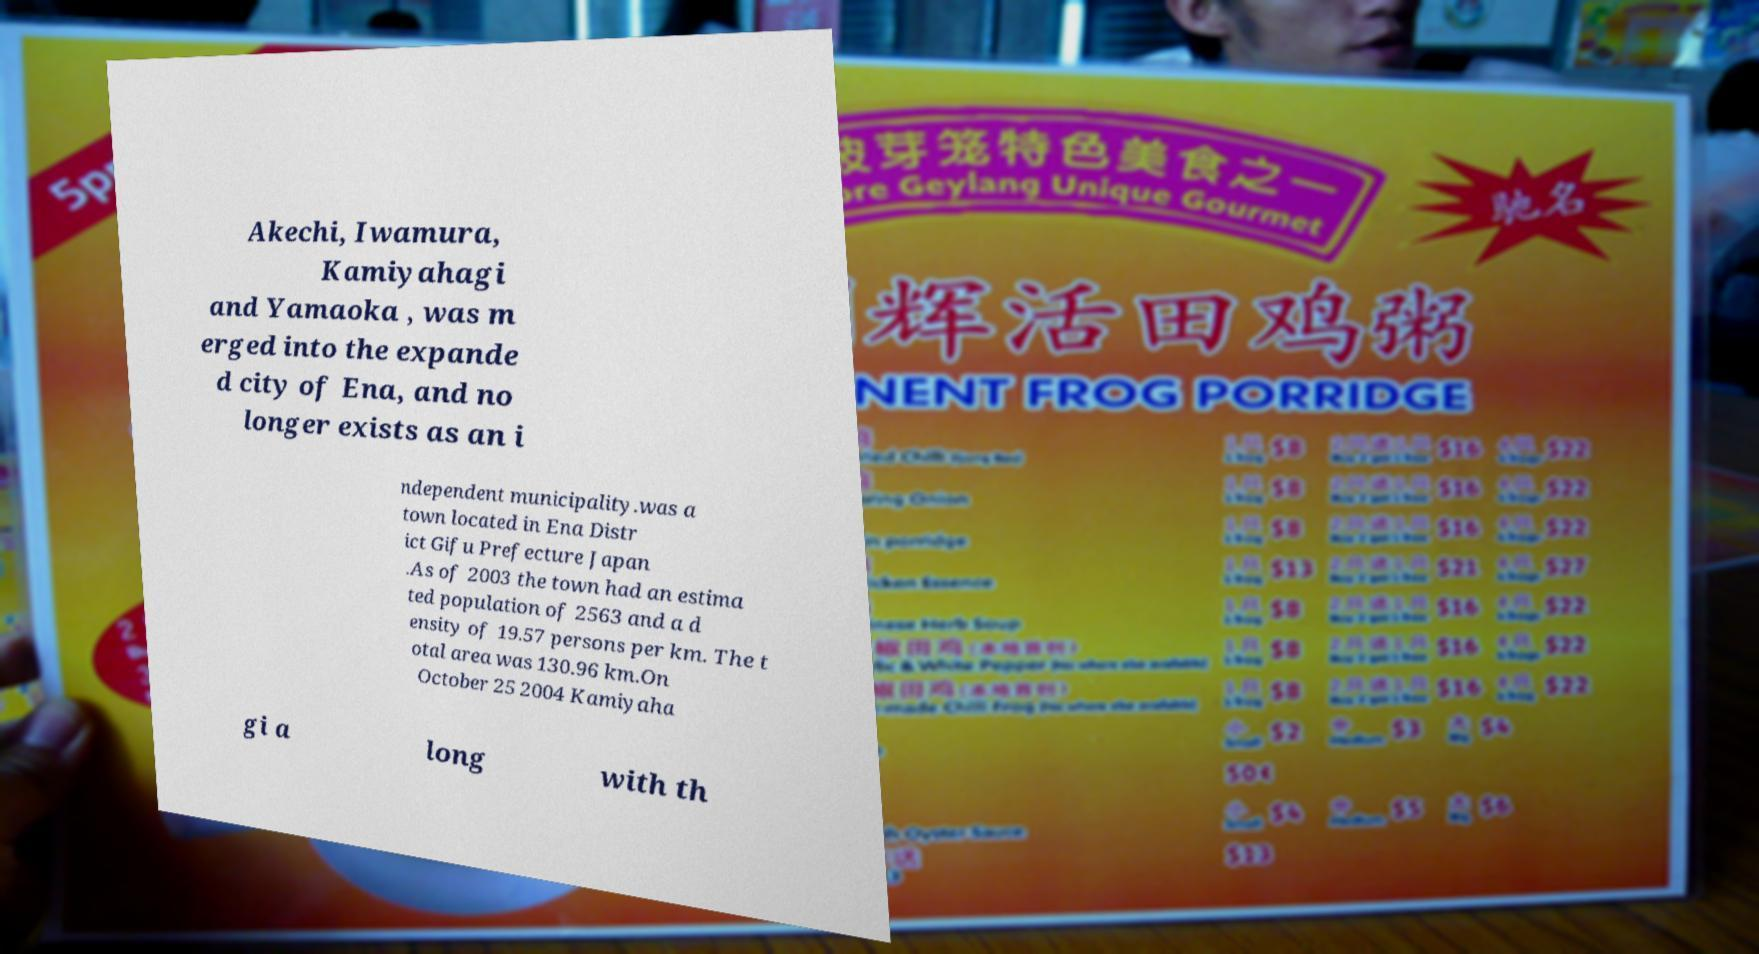There's text embedded in this image that I need extracted. Can you transcribe it verbatim? Akechi, Iwamura, Kamiyahagi and Yamaoka , was m erged into the expande d city of Ena, and no longer exists as an i ndependent municipality.was a town located in Ena Distr ict Gifu Prefecture Japan .As of 2003 the town had an estima ted population of 2563 and a d ensity of 19.57 persons per km. The t otal area was 130.96 km.On October 25 2004 Kamiyaha gi a long with th 